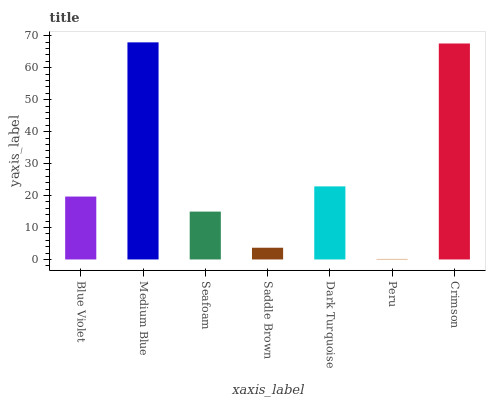Is Peru the minimum?
Answer yes or no. Yes. Is Medium Blue the maximum?
Answer yes or no. Yes. Is Seafoam the minimum?
Answer yes or no. No. Is Seafoam the maximum?
Answer yes or no. No. Is Medium Blue greater than Seafoam?
Answer yes or no. Yes. Is Seafoam less than Medium Blue?
Answer yes or no. Yes. Is Seafoam greater than Medium Blue?
Answer yes or no. No. Is Medium Blue less than Seafoam?
Answer yes or no. No. Is Blue Violet the high median?
Answer yes or no. Yes. Is Blue Violet the low median?
Answer yes or no. Yes. Is Dark Turquoise the high median?
Answer yes or no. No. Is Dark Turquoise the low median?
Answer yes or no. No. 